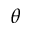Convert formula to latex. <formula><loc_0><loc_0><loc_500><loc_500>\theta</formula> 